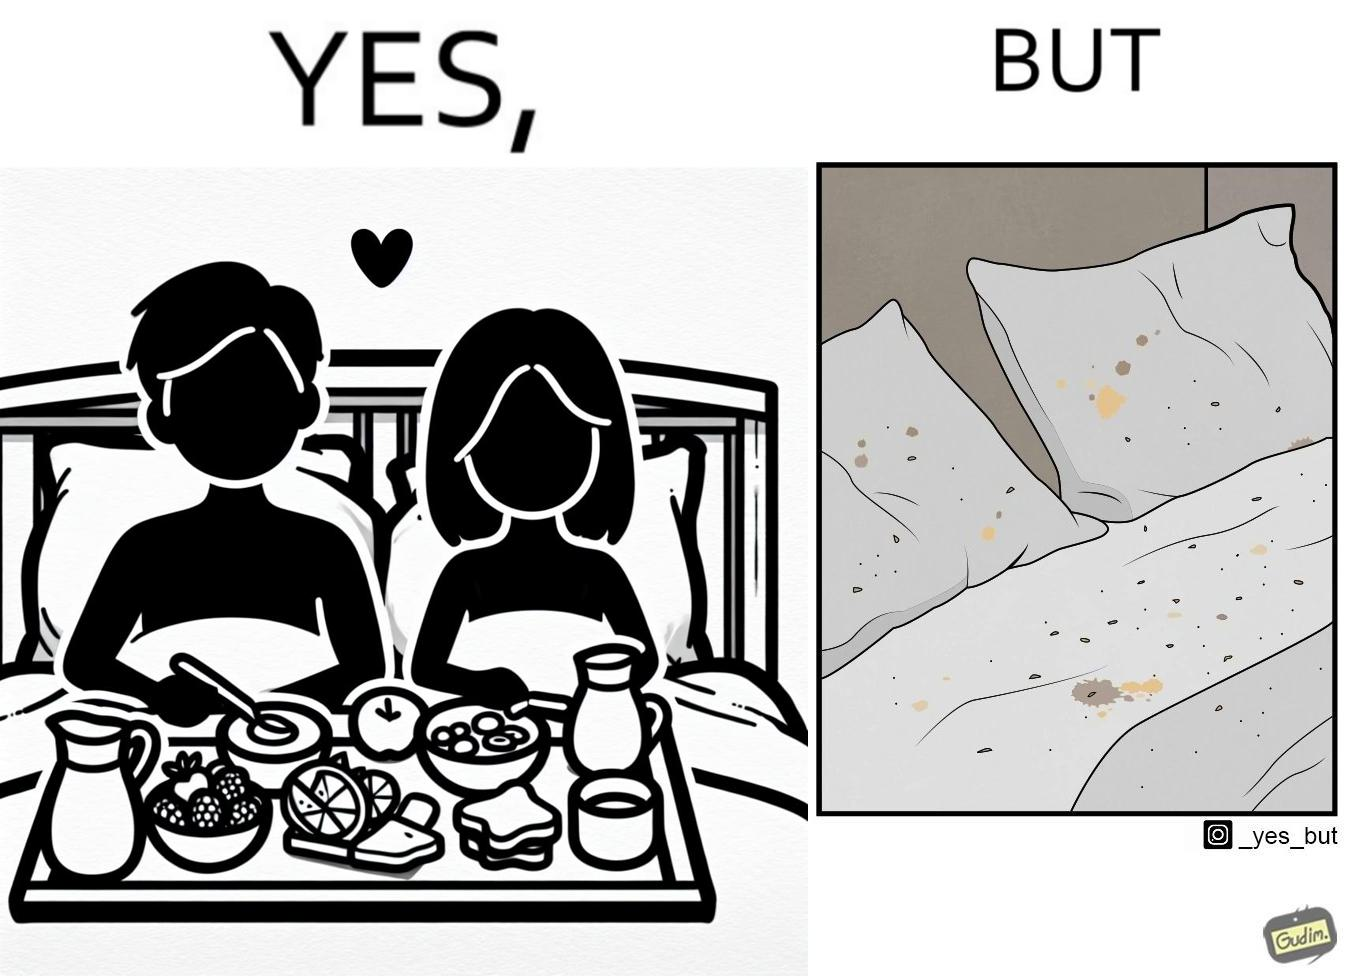Provide a description of this image. The image is ironical, as having breakfast in bed is a luxury. However, eating while in bed leads to food crumbs, making the bed dirty, along with the need to clean the bed afterwards. 